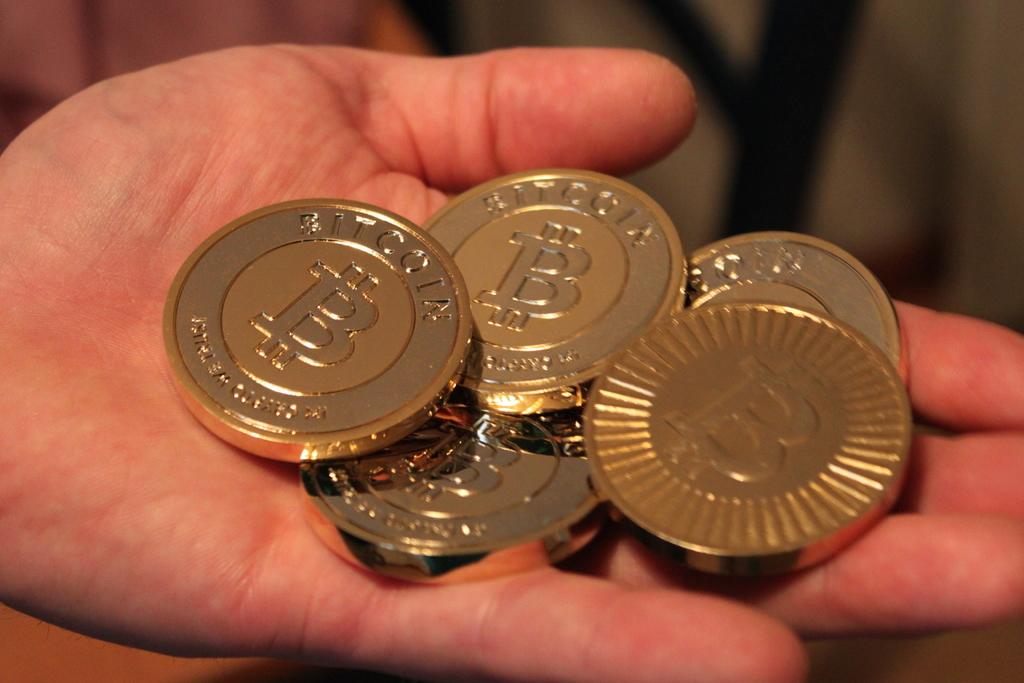<image>
Render a clear and concise summary of the photo. a set of gold Bitcoins in someone's palm. 